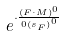<formula> <loc_0><loc_0><loc_500><loc_500>e ^ { \cdot \frac { ( F \cdot M ) ^ { 0 } } { 0 { ( s _ { F } ) } ^ { 0 } } }</formula> 